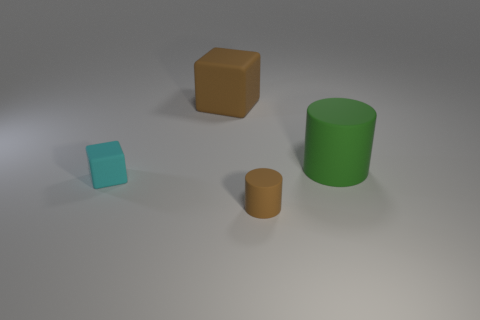There is a brown matte object that is in front of the rubber cube that is in front of the large green matte cylinder; what size is it?
Give a very brief answer. Small. There is a brown thing that is the same material as the big block; what size is it?
Your answer should be compact. Small. How big is the object that is right of the large brown block and to the left of the large cylinder?
Provide a short and direct response. Small. What number of other objects are the same color as the tiny rubber cylinder?
Your answer should be compact. 1. Does the large rubber object that is to the left of the brown cylinder have the same color as the tiny rubber cylinder?
Your answer should be compact. Yes. There is a rubber cylinder that is behind the small brown object; what color is it?
Keep it short and to the point. Green. Are there fewer blocks that are to the left of the large matte block than tiny rubber objects?
Provide a succinct answer. Yes. There is a rubber object that is the same color as the large cube; what size is it?
Offer a terse response. Small. Is the tiny cyan object made of the same material as the green thing?
Provide a succinct answer. Yes. How many things are matte things on the right side of the brown block or matte cylinders to the right of the small brown matte object?
Keep it short and to the point. 2. 